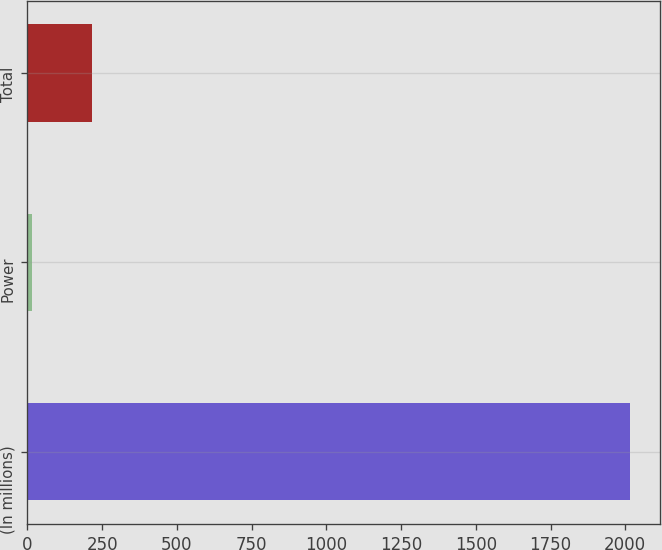Convert chart. <chart><loc_0><loc_0><loc_500><loc_500><bar_chart><fcel>(In millions)<fcel>Power<fcel>Total<nl><fcel>2017<fcel>17<fcel>217<nl></chart> 